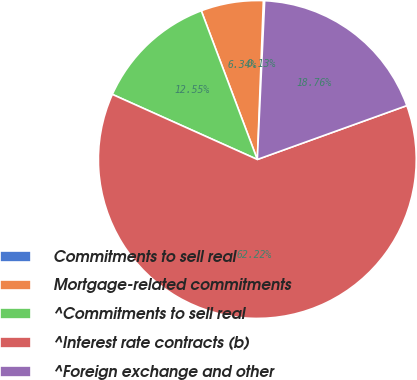<chart> <loc_0><loc_0><loc_500><loc_500><pie_chart><fcel>Commitments to sell real<fcel>Mortgage-related commitments<fcel>^Commitments to sell real<fcel>^Interest rate contracts (b)<fcel>^Foreign exchange and other<nl><fcel>0.13%<fcel>6.34%<fcel>12.55%<fcel>62.22%<fcel>18.76%<nl></chart> 